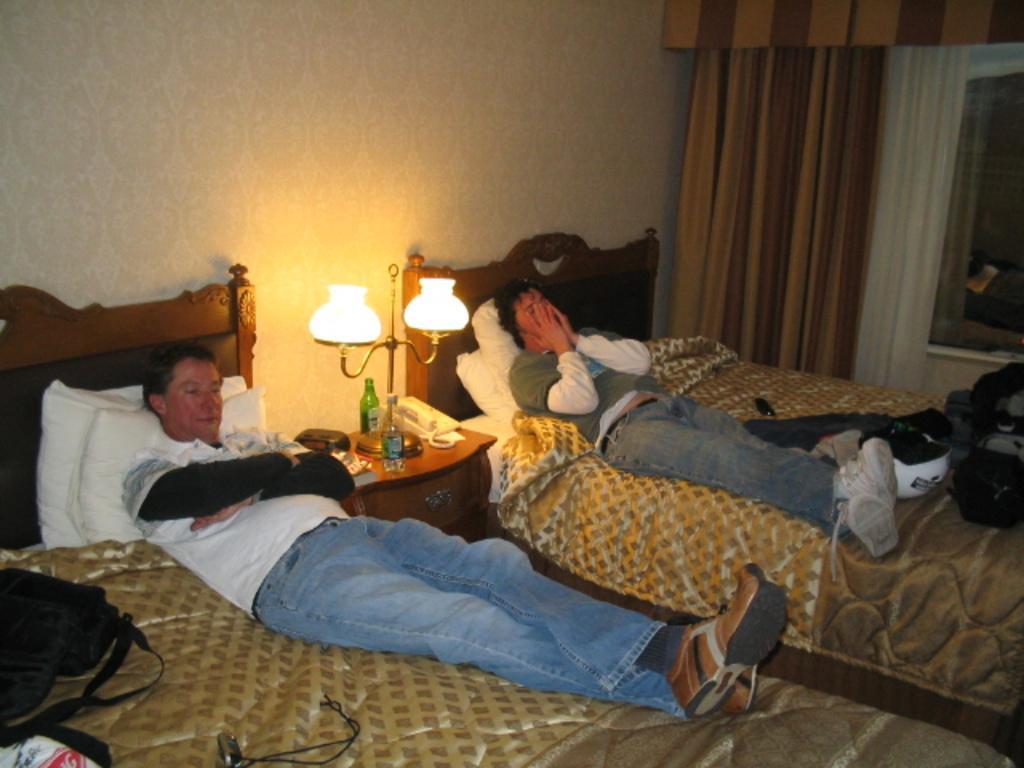In one or two sentences, can you explain what this image depicts? There are two men laying on the bed. Between the beds there is a small table with a lamp,two bottles,telephone are placed on it. I can see a bag placed on the bed. These are the curtains which are used to close the window. 